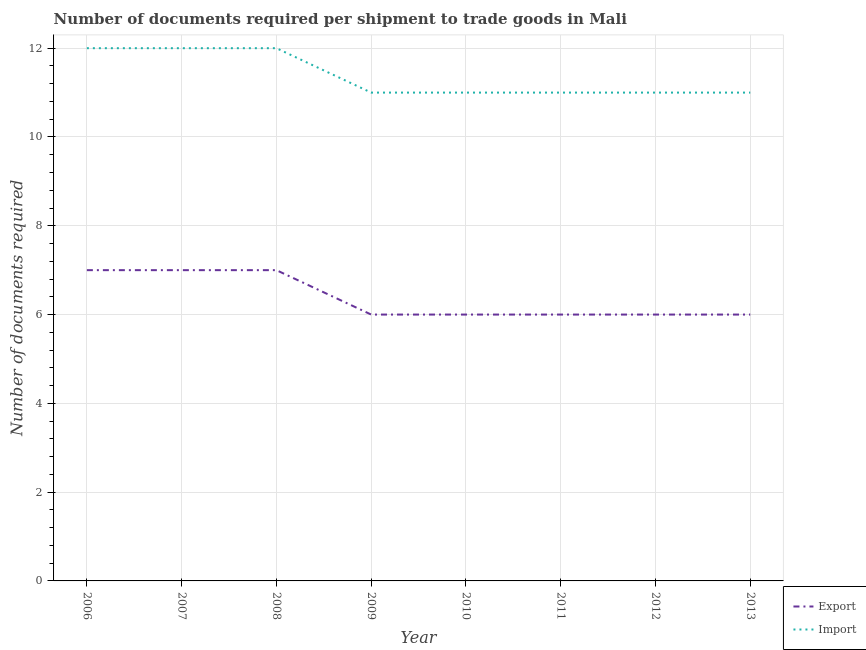Does the line corresponding to number of documents required to export goods intersect with the line corresponding to number of documents required to import goods?
Your answer should be very brief. No. What is the number of documents required to export goods in 2013?
Ensure brevity in your answer.  6. Across all years, what is the maximum number of documents required to export goods?
Keep it short and to the point. 7. Across all years, what is the minimum number of documents required to import goods?
Give a very brief answer. 11. In which year was the number of documents required to import goods minimum?
Offer a very short reply. 2009. What is the total number of documents required to export goods in the graph?
Your answer should be very brief. 51. What is the difference between the number of documents required to export goods in 2006 and that in 2011?
Offer a very short reply. 1. What is the difference between the number of documents required to export goods in 2006 and the number of documents required to import goods in 2008?
Ensure brevity in your answer.  -5. What is the average number of documents required to import goods per year?
Your answer should be very brief. 11.38. In the year 2009, what is the difference between the number of documents required to export goods and number of documents required to import goods?
Provide a short and direct response. -5. What is the ratio of the number of documents required to import goods in 2006 to that in 2009?
Provide a short and direct response. 1.09. Is the number of documents required to import goods in 2007 less than that in 2011?
Ensure brevity in your answer.  No. Is the difference between the number of documents required to export goods in 2006 and 2012 greater than the difference between the number of documents required to import goods in 2006 and 2012?
Keep it short and to the point. No. What is the difference between the highest and the second highest number of documents required to export goods?
Your response must be concise. 0. What is the difference between the highest and the lowest number of documents required to export goods?
Give a very brief answer. 1. Is the sum of the number of documents required to import goods in 2007 and 2012 greater than the maximum number of documents required to export goods across all years?
Ensure brevity in your answer.  Yes. Are the values on the major ticks of Y-axis written in scientific E-notation?
Keep it short and to the point. No. Does the graph contain grids?
Your response must be concise. Yes. Where does the legend appear in the graph?
Offer a terse response. Bottom right. How many legend labels are there?
Your answer should be compact. 2. What is the title of the graph?
Make the answer very short. Number of documents required per shipment to trade goods in Mali. Does "Grants" appear as one of the legend labels in the graph?
Ensure brevity in your answer.  No. What is the label or title of the X-axis?
Offer a terse response. Year. What is the label or title of the Y-axis?
Offer a very short reply. Number of documents required. What is the Number of documents required in Import in 2006?
Offer a terse response. 12. What is the Number of documents required of Import in 2007?
Offer a terse response. 12. What is the Number of documents required in Export in 2008?
Make the answer very short. 7. What is the Number of documents required of Import in 2009?
Make the answer very short. 11. What is the Number of documents required of Export in 2010?
Give a very brief answer. 6. What is the Number of documents required in Export in 2011?
Offer a terse response. 6. What is the Number of documents required of Import in 2011?
Your answer should be compact. 11. What is the Number of documents required in Export in 2013?
Offer a terse response. 6. Across all years, what is the maximum Number of documents required in Export?
Provide a short and direct response. 7. What is the total Number of documents required of Export in the graph?
Give a very brief answer. 51. What is the total Number of documents required in Import in the graph?
Make the answer very short. 91. What is the difference between the Number of documents required of Export in 2006 and that in 2009?
Provide a short and direct response. 1. What is the difference between the Number of documents required of Import in 2006 and that in 2009?
Offer a very short reply. 1. What is the difference between the Number of documents required in Export in 2006 and that in 2011?
Your answer should be compact. 1. What is the difference between the Number of documents required of Import in 2006 and that in 2011?
Your answer should be compact. 1. What is the difference between the Number of documents required in Import in 2006 and that in 2012?
Provide a succinct answer. 1. What is the difference between the Number of documents required in Import in 2007 and that in 2008?
Provide a short and direct response. 0. What is the difference between the Number of documents required in Export in 2007 and that in 2011?
Make the answer very short. 1. What is the difference between the Number of documents required in Import in 2007 and that in 2012?
Make the answer very short. 1. What is the difference between the Number of documents required of Import in 2007 and that in 2013?
Provide a short and direct response. 1. What is the difference between the Number of documents required in Export in 2008 and that in 2009?
Your answer should be very brief. 1. What is the difference between the Number of documents required in Import in 2008 and that in 2009?
Offer a terse response. 1. What is the difference between the Number of documents required in Export in 2008 and that in 2010?
Give a very brief answer. 1. What is the difference between the Number of documents required of Export in 2008 and that in 2011?
Your answer should be very brief. 1. What is the difference between the Number of documents required in Import in 2008 and that in 2011?
Provide a short and direct response. 1. What is the difference between the Number of documents required in Import in 2008 and that in 2012?
Offer a very short reply. 1. What is the difference between the Number of documents required of Import in 2008 and that in 2013?
Provide a short and direct response. 1. What is the difference between the Number of documents required of Import in 2009 and that in 2010?
Your answer should be very brief. 0. What is the difference between the Number of documents required of Export in 2009 and that in 2011?
Offer a very short reply. 0. What is the difference between the Number of documents required of Import in 2009 and that in 2011?
Offer a terse response. 0. What is the difference between the Number of documents required in Import in 2011 and that in 2013?
Give a very brief answer. 0. What is the difference between the Number of documents required in Export in 2006 and the Number of documents required in Import in 2007?
Your response must be concise. -5. What is the difference between the Number of documents required of Export in 2006 and the Number of documents required of Import in 2009?
Provide a short and direct response. -4. What is the difference between the Number of documents required of Export in 2006 and the Number of documents required of Import in 2010?
Offer a very short reply. -4. What is the difference between the Number of documents required of Export in 2006 and the Number of documents required of Import in 2011?
Offer a very short reply. -4. What is the difference between the Number of documents required in Export in 2006 and the Number of documents required in Import in 2012?
Offer a very short reply. -4. What is the difference between the Number of documents required of Export in 2007 and the Number of documents required of Import in 2009?
Make the answer very short. -4. What is the difference between the Number of documents required of Export in 2007 and the Number of documents required of Import in 2012?
Give a very brief answer. -4. What is the difference between the Number of documents required in Export in 2007 and the Number of documents required in Import in 2013?
Offer a very short reply. -4. What is the difference between the Number of documents required of Export in 2008 and the Number of documents required of Import in 2010?
Your answer should be very brief. -4. What is the difference between the Number of documents required in Export in 2008 and the Number of documents required in Import in 2011?
Keep it short and to the point. -4. What is the difference between the Number of documents required in Export in 2008 and the Number of documents required in Import in 2012?
Offer a terse response. -4. What is the difference between the Number of documents required of Export in 2008 and the Number of documents required of Import in 2013?
Give a very brief answer. -4. What is the difference between the Number of documents required of Export in 2009 and the Number of documents required of Import in 2010?
Provide a succinct answer. -5. What is the difference between the Number of documents required of Export in 2009 and the Number of documents required of Import in 2011?
Provide a short and direct response. -5. What is the difference between the Number of documents required in Export in 2010 and the Number of documents required in Import in 2011?
Provide a short and direct response. -5. What is the difference between the Number of documents required in Export in 2010 and the Number of documents required in Import in 2013?
Offer a terse response. -5. What is the difference between the Number of documents required of Export in 2011 and the Number of documents required of Import in 2012?
Your response must be concise. -5. What is the difference between the Number of documents required of Export in 2011 and the Number of documents required of Import in 2013?
Give a very brief answer. -5. What is the average Number of documents required in Export per year?
Offer a terse response. 6.38. What is the average Number of documents required in Import per year?
Make the answer very short. 11.38. In the year 2007, what is the difference between the Number of documents required in Export and Number of documents required in Import?
Offer a terse response. -5. In the year 2009, what is the difference between the Number of documents required of Export and Number of documents required of Import?
Keep it short and to the point. -5. In the year 2011, what is the difference between the Number of documents required in Export and Number of documents required in Import?
Offer a very short reply. -5. In the year 2013, what is the difference between the Number of documents required of Export and Number of documents required of Import?
Offer a terse response. -5. What is the ratio of the Number of documents required in Export in 2006 to that in 2007?
Make the answer very short. 1. What is the ratio of the Number of documents required in Import in 2006 to that in 2007?
Your answer should be compact. 1. What is the ratio of the Number of documents required of Import in 2006 to that in 2008?
Ensure brevity in your answer.  1. What is the ratio of the Number of documents required of Import in 2006 to that in 2009?
Keep it short and to the point. 1.09. What is the ratio of the Number of documents required in Import in 2006 to that in 2010?
Make the answer very short. 1.09. What is the ratio of the Number of documents required of Export in 2006 to that in 2011?
Ensure brevity in your answer.  1.17. What is the ratio of the Number of documents required in Import in 2006 to that in 2011?
Keep it short and to the point. 1.09. What is the ratio of the Number of documents required of Export in 2006 to that in 2012?
Provide a short and direct response. 1.17. What is the ratio of the Number of documents required of Import in 2006 to that in 2013?
Provide a short and direct response. 1.09. What is the ratio of the Number of documents required of Import in 2007 to that in 2008?
Ensure brevity in your answer.  1. What is the ratio of the Number of documents required of Export in 2007 to that in 2009?
Ensure brevity in your answer.  1.17. What is the ratio of the Number of documents required in Export in 2007 to that in 2010?
Give a very brief answer. 1.17. What is the ratio of the Number of documents required of Export in 2007 to that in 2011?
Offer a terse response. 1.17. What is the ratio of the Number of documents required in Import in 2007 to that in 2012?
Your answer should be compact. 1.09. What is the ratio of the Number of documents required in Import in 2007 to that in 2013?
Offer a very short reply. 1.09. What is the ratio of the Number of documents required of Export in 2008 to that in 2009?
Offer a terse response. 1.17. What is the ratio of the Number of documents required of Export in 2008 to that in 2012?
Keep it short and to the point. 1.17. What is the ratio of the Number of documents required in Import in 2008 to that in 2012?
Your answer should be compact. 1.09. What is the ratio of the Number of documents required in Export in 2009 to that in 2010?
Offer a terse response. 1. What is the ratio of the Number of documents required in Import in 2009 to that in 2010?
Provide a short and direct response. 1. What is the ratio of the Number of documents required in Import in 2009 to that in 2011?
Offer a very short reply. 1. What is the ratio of the Number of documents required of Export in 2009 to that in 2013?
Offer a terse response. 1. What is the ratio of the Number of documents required of Import in 2009 to that in 2013?
Offer a terse response. 1. What is the ratio of the Number of documents required of Export in 2010 to that in 2011?
Your response must be concise. 1. What is the ratio of the Number of documents required in Import in 2010 to that in 2013?
Offer a terse response. 1. What is the ratio of the Number of documents required in Export in 2011 to that in 2012?
Provide a succinct answer. 1. What is the ratio of the Number of documents required in Import in 2011 to that in 2012?
Ensure brevity in your answer.  1. What is the ratio of the Number of documents required in Export in 2011 to that in 2013?
Offer a terse response. 1. What is the ratio of the Number of documents required of Import in 2012 to that in 2013?
Provide a succinct answer. 1. What is the difference between the highest and the second highest Number of documents required of Export?
Provide a short and direct response. 0. What is the difference between the highest and the second highest Number of documents required in Import?
Offer a very short reply. 0. What is the difference between the highest and the lowest Number of documents required of Export?
Your answer should be very brief. 1. 